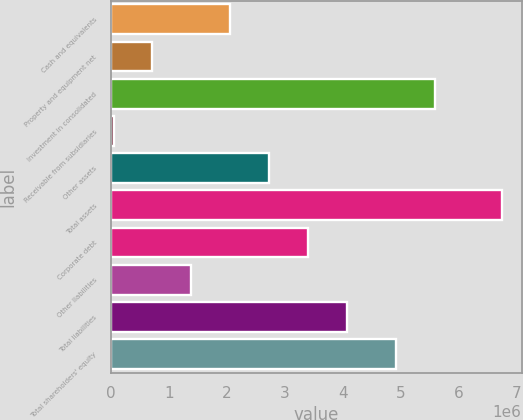<chart> <loc_0><loc_0><loc_500><loc_500><bar_chart><fcel>Cash and equivalents<fcel>Property and equipment net<fcel>Investment in consolidated<fcel>Receivable from subsidiaries<fcel>Other assets<fcel>Total assets<fcel>Corporate debt<fcel>Other liabilities<fcel>Total liabilities<fcel>Total shareholders' equity<nl><fcel>2.05451e+06<fcel>712109<fcel>5.59915e+06<fcel>40906<fcel>2.72572e+06<fcel>6.75293e+06<fcel>3.39692e+06<fcel>1.38331e+06<fcel>4.06812e+06<fcel>4.92795e+06<nl></chart> 